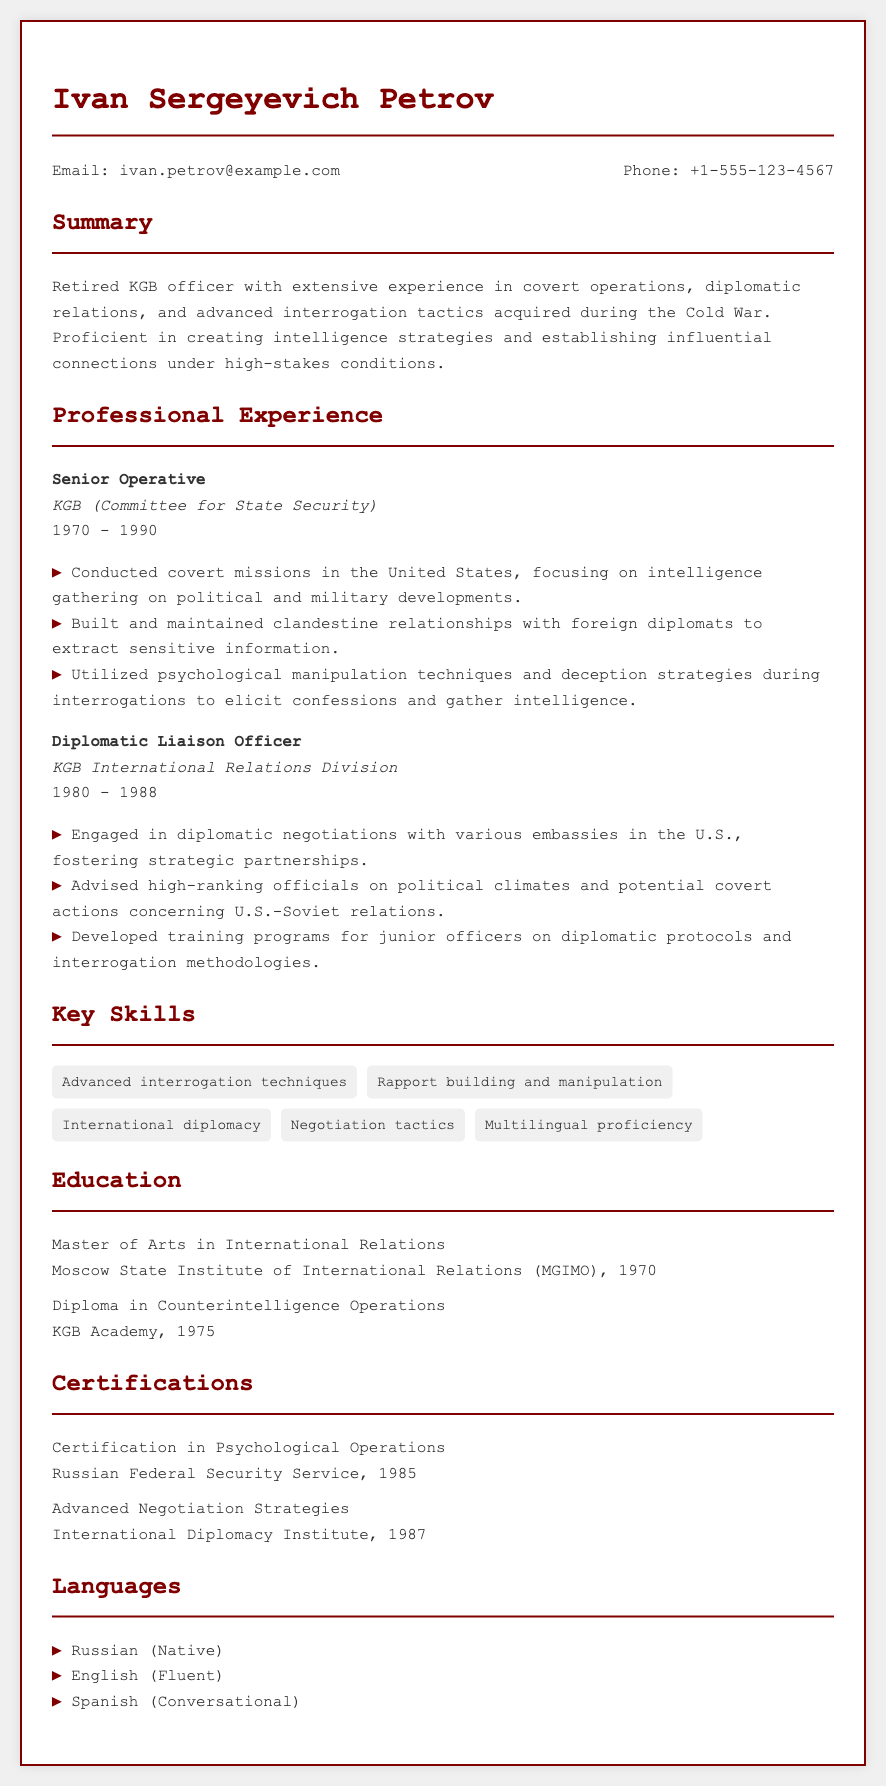what is the name of the individual in this CV? The name is prominently displayed at the top of the document under the title.
Answer: Ivan Sergeyevich Petrov what position did Ivan hold from 1970 to 1990? The document specifies the job title alongside the organization and time period.
Answer: Senior Operative which organization did Ivan work for as a Diplomatic Liaison Officer? The document provides the organizational affiliation of the position mentioned.
Answer: KGB International Relations Division how many languages is Ivan proficient in? The section enumerates the languages spoken by Ivan.
Answer: Three what year did Ivan complete his Master's degree? The education section includes the completion year for his degree.
Answer: 1970 which certification did Ivan receive from the Russian Federal Security Service? The document lists his certifications along with the issuing organization.
Answer: Certification in Psychological Operations what was one of Ivan's key skills? The key skills section includes various capabilities for quick reference.
Answer: Advanced interrogation techniques in what year did Ivan complete his Diploma in Counterintelligence Operations? The education section contains the year he finished his diploma.
Answer: 1975 who advised high-ranking officials on political climates during Ivan's career? The document indicates Ivan's responsibilities and advisory roles.
Answer: Ivan Petrov 